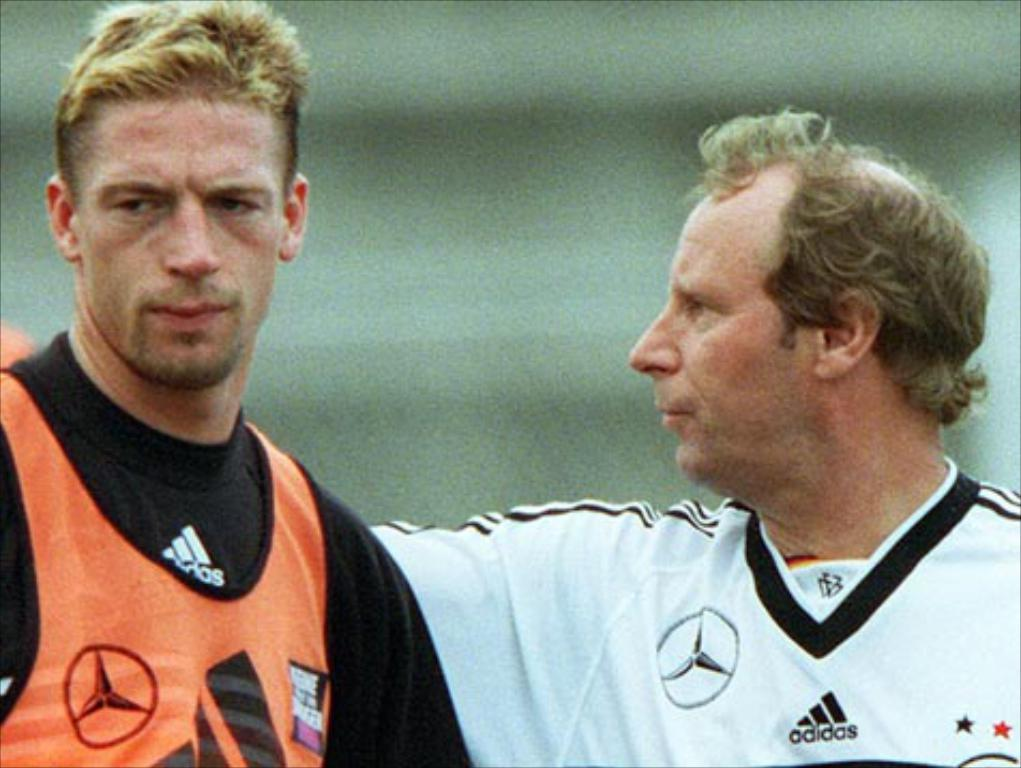<image>
Relay a brief, clear account of the picture shown. the name adidas is on the shirt of the person 